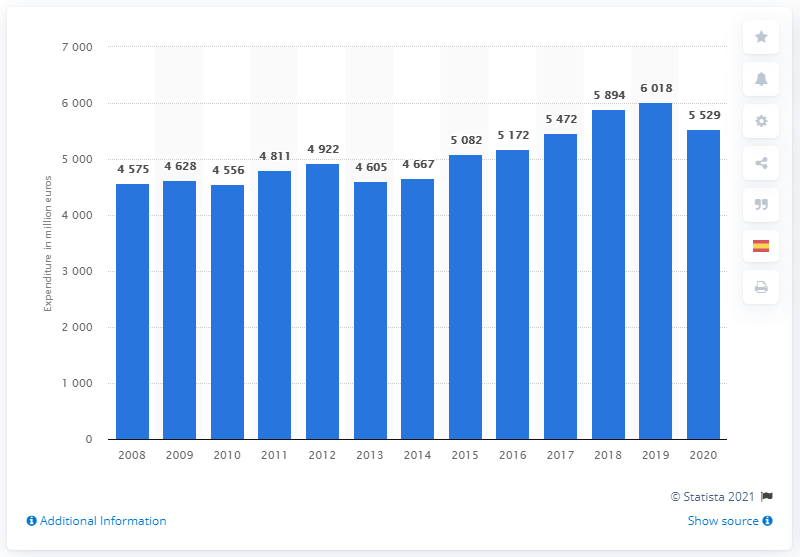List a handful of essential elements in this visual. Sanofi first increased its R&D expenditures in 2013. Sanofi spent 5,529 million dollars on research and development in 2020. 